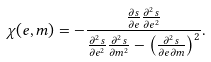<formula> <loc_0><loc_0><loc_500><loc_500>\chi ( e , m ) = - \frac { \frac { \partial s } { \partial e } \frac { \partial ^ { 2 } s } { \partial e ^ { 2 } } } { \frac { \partial ^ { 2 } s } { \partial e ^ { 2 } } \frac { \partial ^ { 2 } s } { \partial m ^ { 2 } } - \left ( \frac { \partial ^ { 2 } s } { \partial e \partial m } \right ) ^ { 2 } } .</formula> 